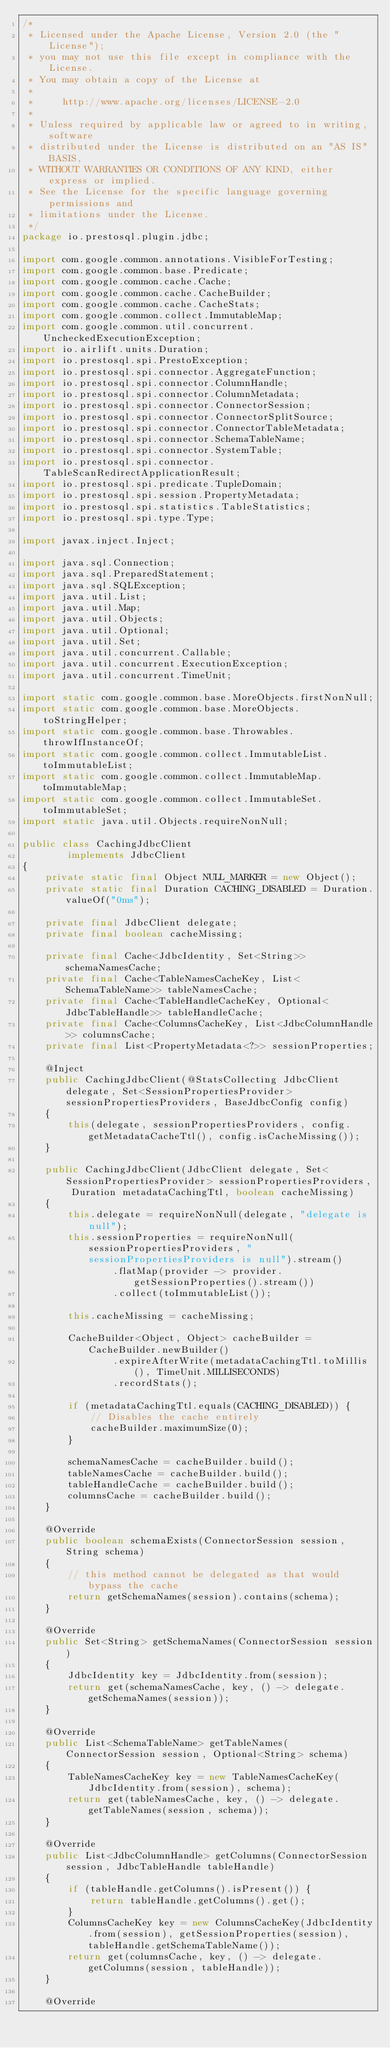<code> <loc_0><loc_0><loc_500><loc_500><_Java_>/*
 * Licensed under the Apache License, Version 2.0 (the "License");
 * you may not use this file except in compliance with the License.
 * You may obtain a copy of the License at
 *
 *     http://www.apache.org/licenses/LICENSE-2.0
 *
 * Unless required by applicable law or agreed to in writing, software
 * distributed under the License is distributed on an "AS IS" BASIS,
 * WITHOUT WARRANTIES OR CONDITIONS OF ANY KIND, either express or implied.
 * See the License for the specific language governing permissions and
 * limitations under the License.
 */
package io.prestosql.plugin.jdbc;

import com.google.common.annotations.VisibleForTesting;
import com.google.common.base.Predicate;
import com.google.common.cache.Cache;
import com.google.common.cache.CacheBuilder;
import com.google.common.cache.CacheStats;
import com.google.common.collect.ImmutableMap;
import com.google.common.util.concurrent.UncheckedExecutionException;
import io.airlift.units.Duration;
import io.prestosql.spi.PrestoException;
import io.prestosql.spi.connector.AggregateFunction;
import io.prestosql.spi.connector.ColumnHandle;
import io.prestosql.spi.connector.ColumnMetadata;
import io.prestosql.spi.connector.ConnectorSession;
import io.prestosql.spi.connector.ConnectorSplitSource;
import io.prestosql.spi.connector.ConnectorTableMetadata;
import io.prestosql.spi.connector.SchemaTableName;
import io.prestosql.spi.connector.SystemTable;
import io.prestosql.spi.connector.TableScanRedirectApplicationResult;
import io.prestosql.spi.predicate.TupleDomain;
import io.prestosql.spi.session.PropertyMetadata;
import io.prestosql.spi.statistics.TableStatistics;
import io.prestosql.spi.type.Type;

import javax.inject.Inject;

import java.sql.Connection;
import java.sql.PreparedStatement;
import java.sql.SQLException;
import java.util.List;
import java.util.Map;
import java.util.Objects;
import java.util.Optional;
import java.util.Set;
import java.util.concurrent.Callable;
import java.util.concurrent.ExecutionException;
import java.util.concurrent.TimeUnit;

import static com.google.common.base.MoreObjects.firstNonNull;
import static com.google.common.base.MoreObjects.toStringHelper;
import static com.google.common.base.Throwables.throwIfInstanceOf;
import static com.google.common.collect.ImmutableList.toImmutableList;
import static com.google.common.collect.ImmutableMap.toImmutableMap;
import static com.google.common.collect.ImmutableSet.toImmutableSet;
import static java.util.Objects.requireNonNull;

public class CachingJdbcClient
        implements JdbcClient
{
    private static final Object NULL_MARKER = new Object();
    private static final Duration CACHING_DISABLED = Duration.valueOf("0ms");

    private final JdbcClient delegate;
    private final boolean cacheMissing;

    private final Cache<JdbcIdentity, Set<String>> schemaNamesCache;
    private final Cache<TableNamesCacheKey, List<SchemaTableName>> tableNamesCache;
    private final Cache<TableHandleCacheKey, Optional<JdbcTableHandle>> tableHandleCache;
    private final Cache<ColumnsCacheKey, List<JdbcColumnHandle>> columnsCache;
    private final List<PropertyMetadata<?>> sessionProperties;

    @Inject
    public CachingJdbcClient(@StatsCollecting JdbcClient delegate, Set<SessionPropertiesProvider> sessionPropertiesProviders, BaseJdbcConfig config)
    {
        this(delegate, sessionPropertiesProviders, config.getMetadataCacheTtl(), config.isCacheMissing());
    }

    public CachingJdbcClient(JdbcClient delegate, Set<SessionPropertiesProvider> sessionPropertiesProviders, Duration metadataCachingTtl, boolean cacheMissing)
    {
        this.delegate = requireNonNull(delegate, "delegate is null");
        this.sessionProperties = requireNonNull(sessionPropertiesProviders, "sessionPropertiesProviders is null").stream()
                .flatMap(provider -> provider.getSessionProperties().stream())
                .collect(toImmutableList());

        this.cacheMissing = cacheMissing;

        CacheBuilder<Object, Object> cacheBuilder = CacheBuilder.newBuilder()
                .expireAfterWrite(metadataCachingTtl.toMillis(), TimeUnit.MILLISECONDS)
                .recordStats();

        if (metadataCachingTtl.equals(CACHING_DISABLED)) {
            // Disables the cache entirely
            cacheBuilder.maximumSize(0);
        }

        schemaNamesCache = cacheBuilder.build();
        tableNamesCache = cacheBuilder.build();
        tableHandleCache = cacheBuilder.build();
        columnsCache = cacheBuilder.build();
    }

    @Override
    public boolean schemaExists(ConnectorSession session, String schema)
    {
        // this method cannot be delegated as that would bypass the cache
        return getSchemaNames(session).contains(schema);
    }

    @Override
    public Set<String> getSchemaNames(ConnectorSession session)
    {
        JdbcIdentity key = JdbcIdentity.from(session);
        return get(schemaNamesCache, key, () -> delegate.getSchemaNames(session));
    }

    @Override
    public List<SchemaTableName> getTableNames(ConnectorSession session, Optional<String> schema)
    {
        TableNamesCacheKey key = new TableNamesCacheKey(JdbcIdentity.from(session), schema);
        return get(tableNamesCache, key, () -> delegate.getTableNames(session, schema));
    }

    @Override
    public List<JdbcColumnHandle> getColumns(ConnectorSession session, JdbcTableHandle tableHandle)
    {
        if (tableHandle.getColumns().isPresent()) {
            return tableHandle.getColumns().get();
        }
        ColumnsCacheKey key = new ColumnsCacheKey(JdbcIdentity.from(session), getSessionProperties(session), tableHandle.getSchemaTableName());
        return get(columnsCache, key, () -> delegate.getColumns(session, tableHandle));
    }

    @Override</code> 